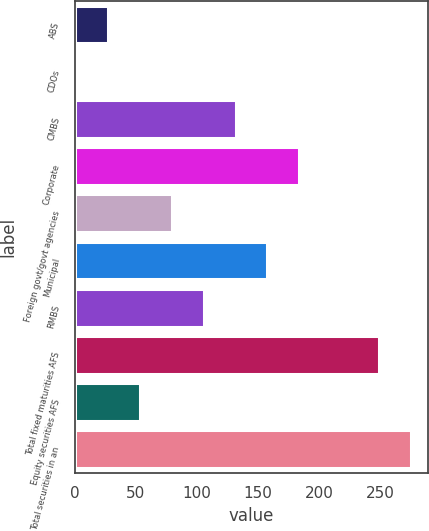Convert chart to OTSL. <chart><loc_0><loc_0><loc_500><loc_500><bar_chart><fcel>ABS<fcel>CDOs<fcel>CMBS<fcel>Corporate<fcel>Foreign govt/govt agencies<fcel>Municipal<fcel>RMBS<fcel>Total fixed maturities AFS<fcel>Equity securities AFS<fcel>Total securities in an<nl><fcel>27.1<fcel>1<fcel>131.5<fcel>183.7<fcel>79.3<fcel>157.6<fcel>105.4<fcel>249<fcel>53.2<fcel>275.1<nl></chart> 